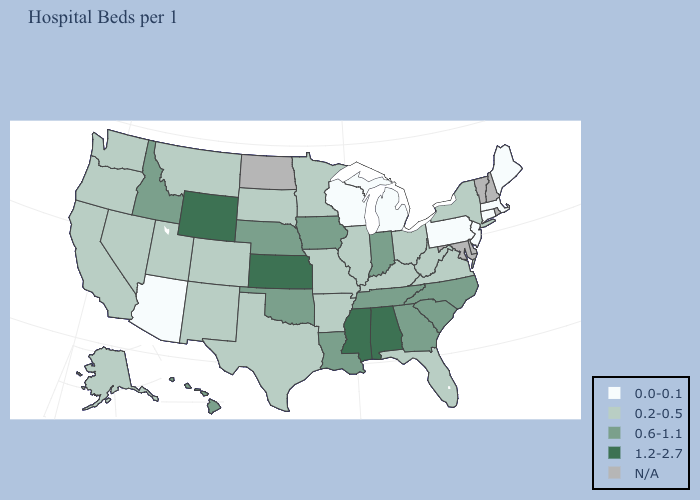How many symbols are there in the legend?
Be succinct. 5. Which states have the lowest value in the USA?
Concise answer only. Arizona, Connecticut, Maine, Massachusetts, Michigan, New Jersey, Pennsylvania, Wisconsin. Name the states that have a value in the range N/A?
Concise answer only. Delaware, Maryland, New Hampshire, North Dakota, Rhode Island, Vermont. Among the states that border Oklahoma , does Arkansas have the lowest value?
Short answer required. Yes. Name the states that have a value in the range 1.2-2.7?
Write a very short answer. Alabama, Kansas, Mississippi, Wyoming. Which states hav the highest value in the MidWest?
Quick response, please. Kansas. Which states hav the highest value in the Northeast?
Quick response, please. New York. What is the lowest value in the West?
Concise answer only. 0.0-0.1. Name the states that have a value in the range 0.0-0.1?
Be succinct. Arizona, Connecticut, Maine, Massachusetts, Michigan, New Jersey, Pennsylvania, Wisconsin. What is the value of Missouri?
Short answer required. 0.2-0.5. Among the states that border Oklahoma , which have the highest value?
Give a very brief answer. Kansas. Which states have the lowest value in the MidWest?
Concise answer only. Michigan, Wisconsin. 